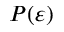Convert formula to latex. <formula><loc_0><loc_0><loc_500><loc_500>P ( \varepsilon )</formula> 